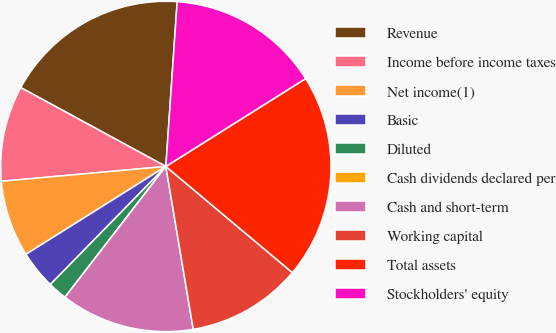<chart> <loc_0><loc_0><loc_500><loc_500><pie_chart><fcel>Revenue<fcel>Income before income taxes<fcel>Net income(1)<fcel>Basic<fcel>Diluted<fcel>Cash dividends declared per<fcel>Cash and short-term<fcel>Working capital<fcel>Total assets<fcel>Stockholders' equity<nl><fcel>18.17%<fcel>9.36%<fcel>7.49%<fcel>3.75%<fcel>1.87%<fcel>0.0%<fcel>13.11%<fcel>11.24%<fcel>20.04%<fcel>14.98%<nl></chart> 